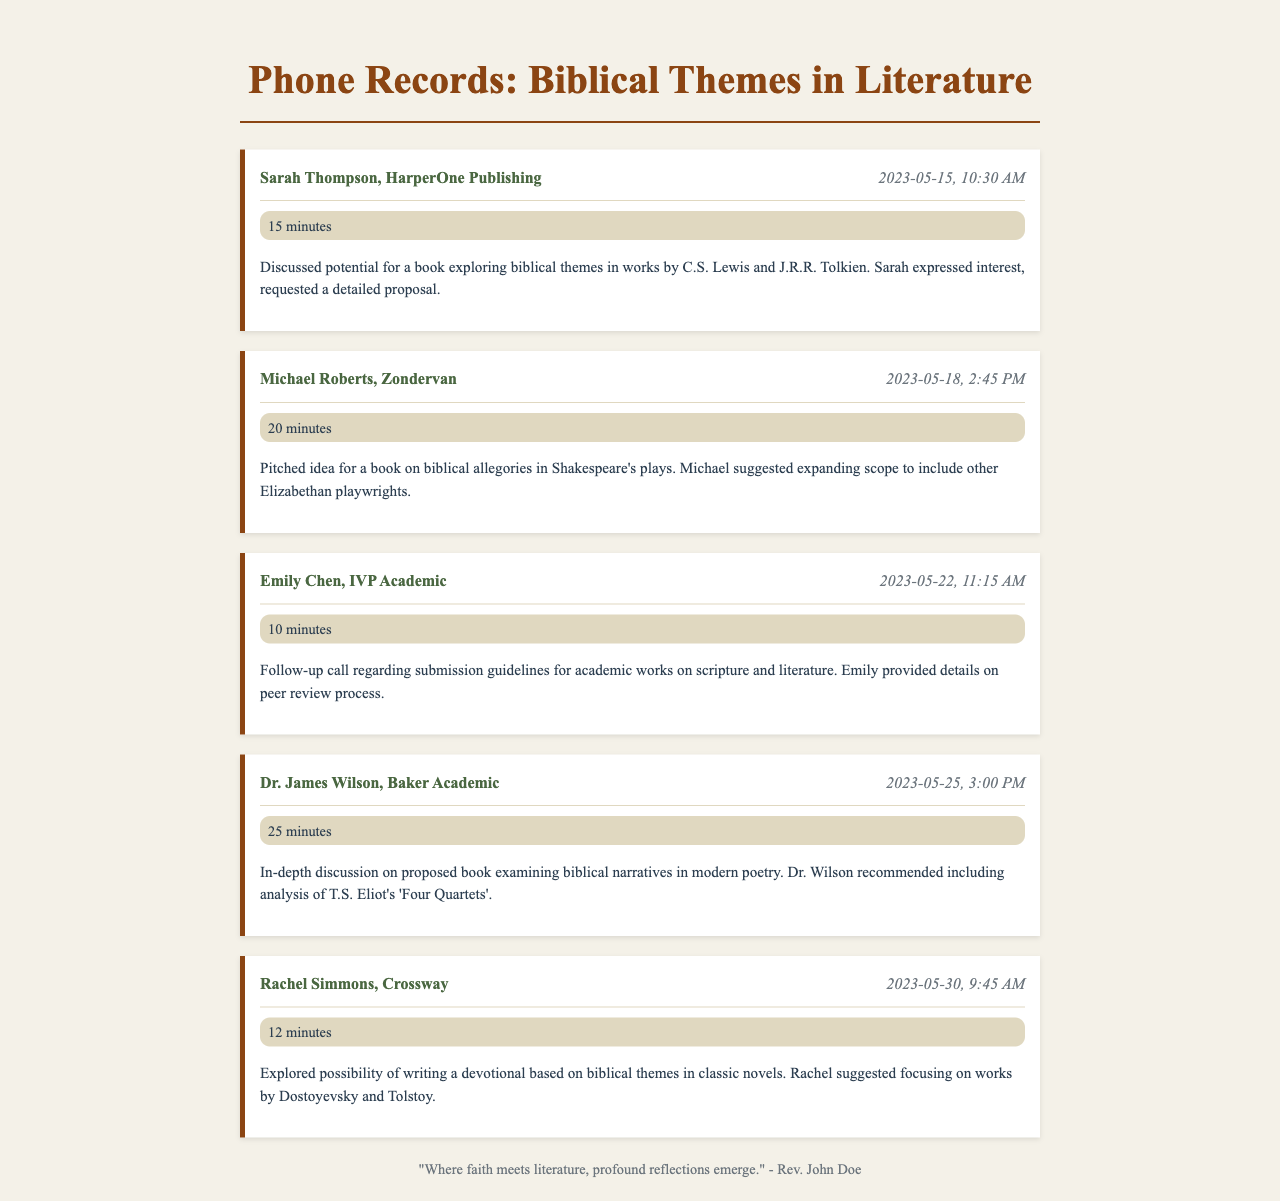What is the name of the publisher Sarah Thompson works for? Sarah Thompson is associated with HarperOne Publishing as noted in the record.
Answer: HarperOne Publishing On what date did the call with Michael Roberts take place? The call with Michael Roberts occurred on May 18, 2023, as seen in the document.
Answer: 2023-05-18 How long was the conversation with Dr. James Wilson? The document states the conversation with Dr. James Wilson lasted for 25 minutes.
Answer: 25 minutes What was the main topic discussed during the call with Emily Chen? The main topic discussed with Emily Chen was submission guidelines for academic works, as indicated in the notes.
Answer: Submission guidelines Which author did Dr. Wilson recommend for analysis in the proposed book? Dr. Wilson recommended including T.S. Eliot's 'Four Quartets' during the discussion.
Answer: T.S. Eliot What was Rachel Simmons's suggestion for the devotional? Rachel Simmons suggested focusing on works by Dostoyevsky and Tolstoy for the devotional based on biblical themes.
Answer: Dostoyevsky and Tolstoy 